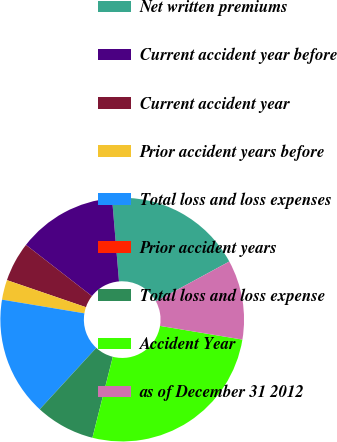Convert chart to OTSL. <chart><loc_0><loc_0><loc_500><loc_500><pie_chart><fcel>Net written premiums<fcel>Current accident year before<fcel>Current accident year<fcel>Prior accident years before<fcel>Total loss and loss expenses<fcel>Prior accident years<fcel>Total loss and loss expense<fcel>Accident Year<fcel>as of December 31 2012<nl><fcel>18.42%<fcel>13.16%<fcel>5.26%<fcel>2.63%<fcel>15.79%<fcel>0.0%<fcel>7.9%<fcel>26.31%<fcel>10.53%<nl></chart> 